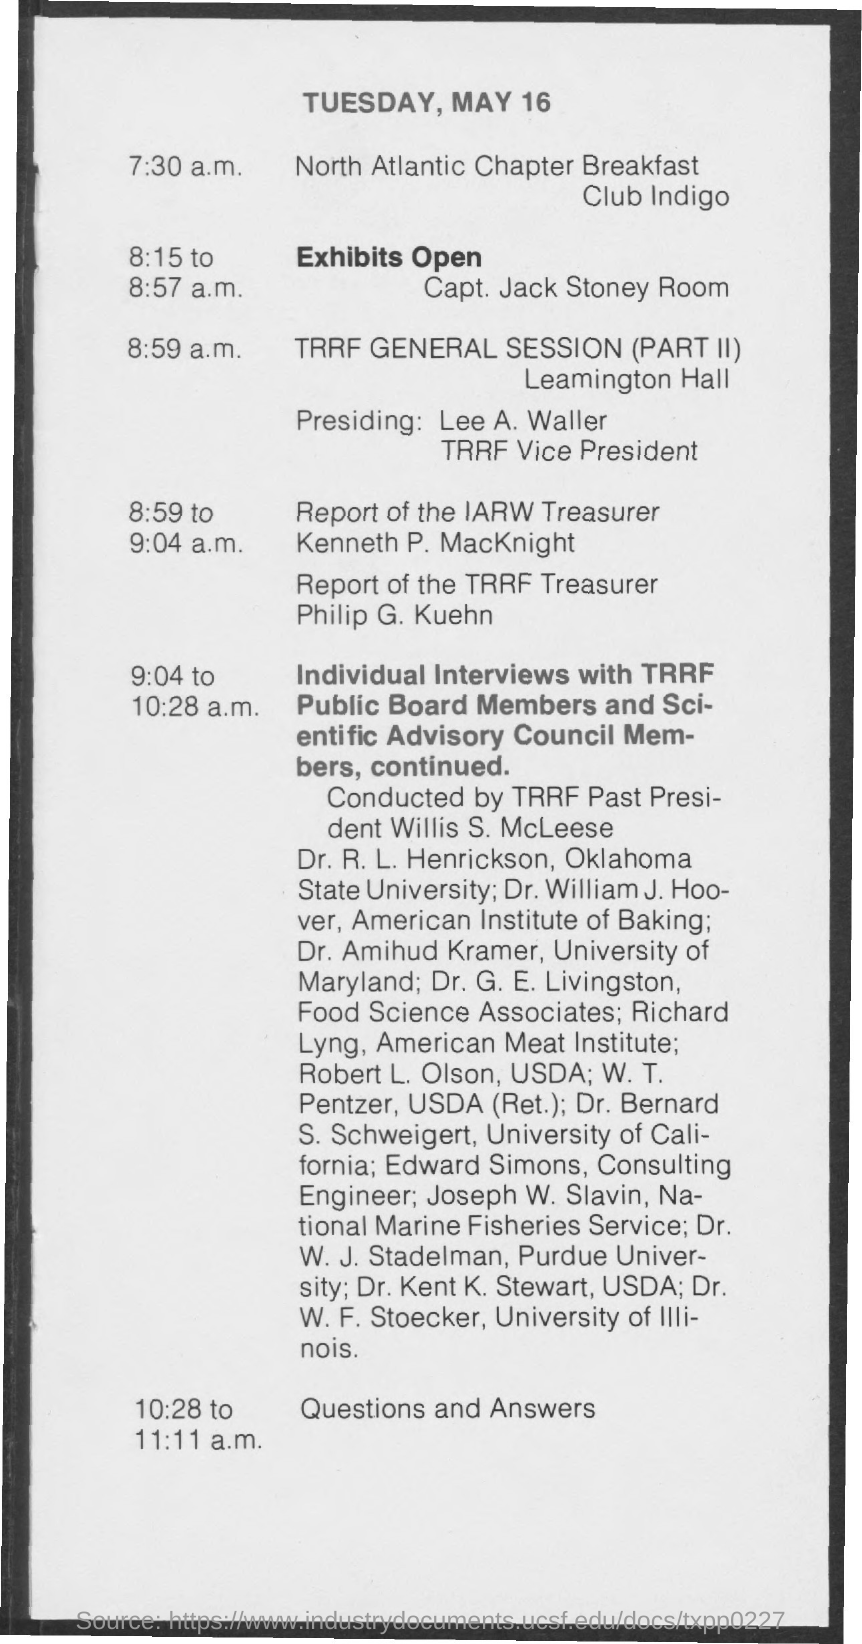List a handful of essential elements in this visual. Lee A. Waller is the Vice President of TRRF. Edward Simons is a consulting engineer with a designated title. The person presiding over the session is Lee A. Waller. Willis S. McLeese was the past president of TRRF. 